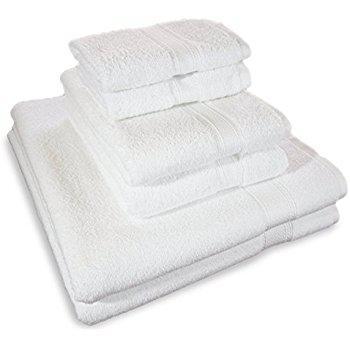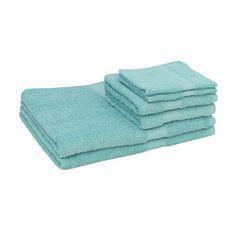The first image is the image on the left, the second image is the image on the right. Examine the images to the left and right. Is the description "An image shows a stack of at least two solid gray towels." accurate? Answer yes or no. No. 